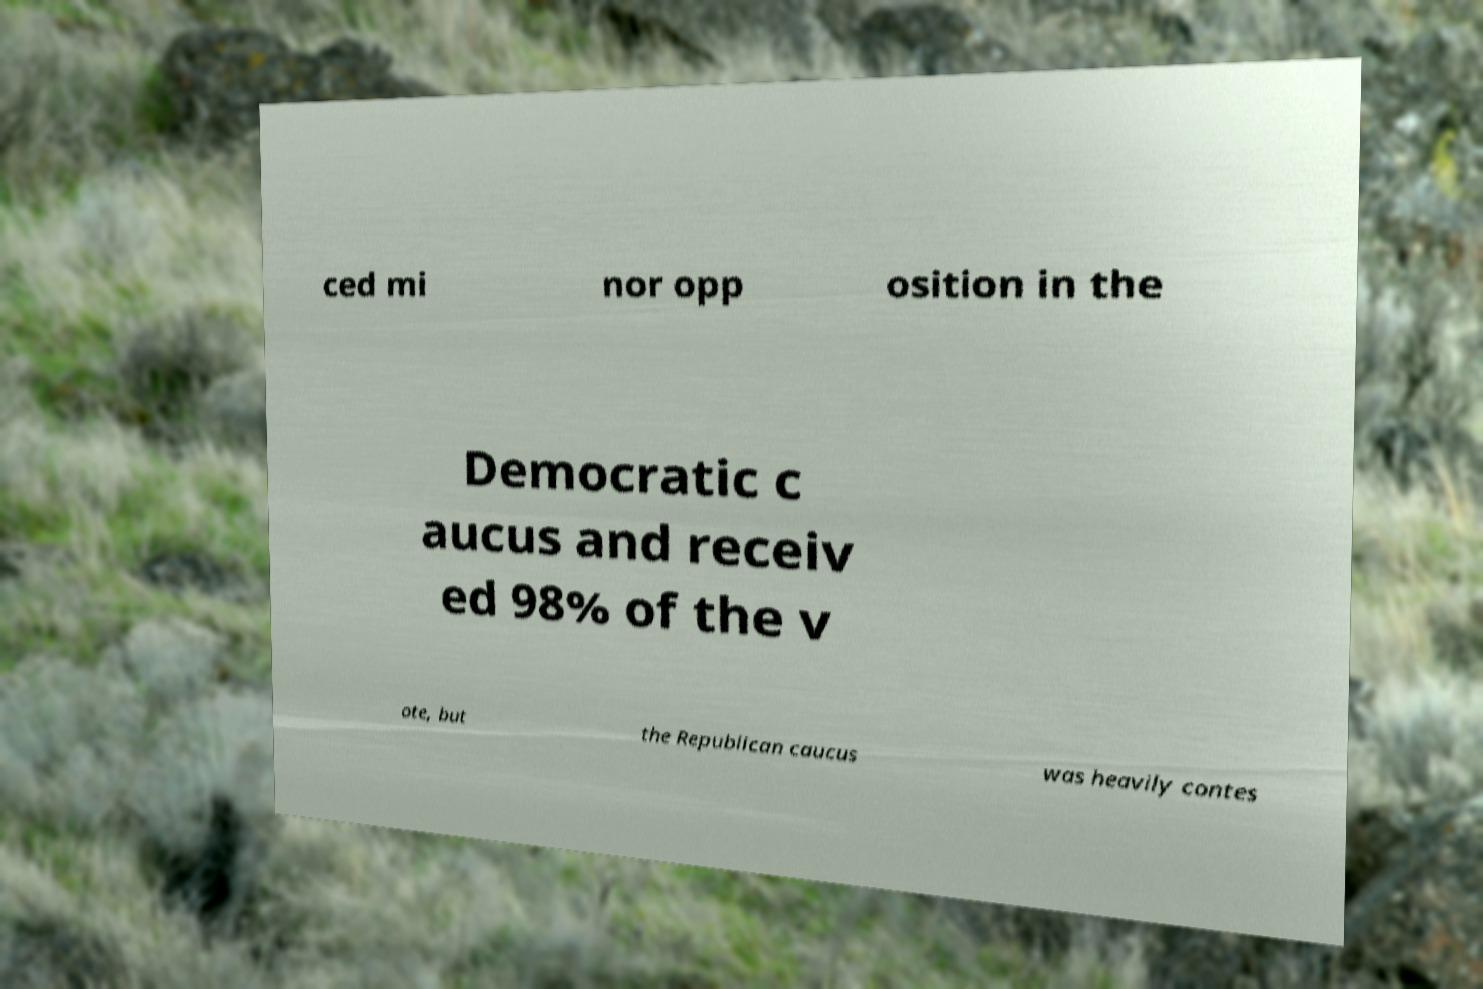I need the written content from this picture converted into text. Can you do that? ced mi nor opp osition in the Democratic c aucus and receiv ed 98% of the v ote, but the Republican caucus was heavily contes 